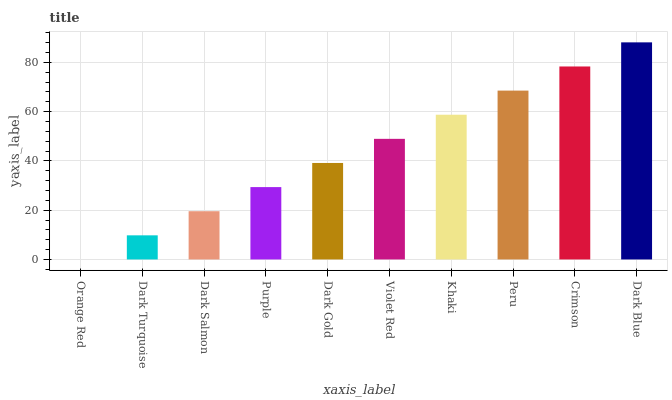Is Orange Red the minimum?
Answer yes or no. Yes. Is Dark Blue the maximum?
Answer yes or no. Yes. Is Dark Turquoise the minimum?
Answer yes or no. No. Is Dark Turquoise the maximum?
Answer yes or no. No. Is Dark Turquoise greater than Orange Red?
Answer yes or no. Yes. Is Orange Red less than Dark Turquoise?
Answer yes or no. Yes. Is Orange Red greater than Dark Turquoise?
Answer yes or no. No. Is Dark Turquoise less than Orange Red?
Answer yes or no. No. Is Violet Red the high median?
Answer yes or no. Yes. Is Dark Gold the low median?
Answer yes or no. Yes. Is Peru the high median?
Answer yes or no. No. Is Orange Red the low median?
Answer yes or no. No. 